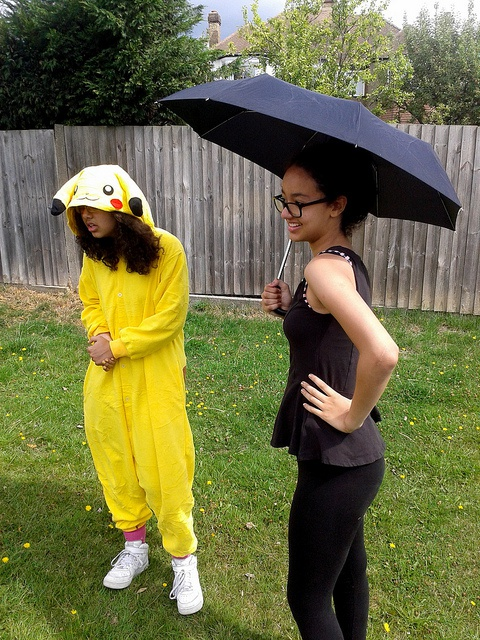Describe the objects in this image and their specific colors. I can see people in lightblue, black, olive, and gray tones, people in lightblue, gold, white, and black tones, and umbrella in lightblue, black, gray, and darkgray tones in this image. 